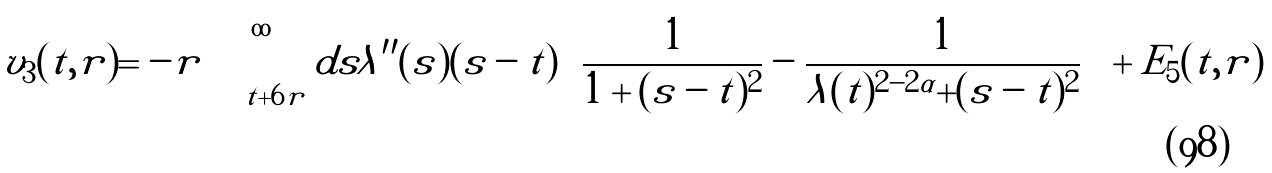<formula> <loc_0><loc_0><loc_500><loc_500>v _ { 3 } ( t , r ) = - r \int _ { t + 6 r } ^ { \infty } d s \lambda ^ { \prime \prime } ( s ) ( s - t ) \left ( \frac { 1 } { 1 + ( s - t ) ^ { 2 } } - \frac { 1 } { \lambda ( t ) ^ { 2 - 2 \alpha } + ( s - t ) ^ { 2 } } \right ) + E _ { 5 } ( t , r )</formula> 